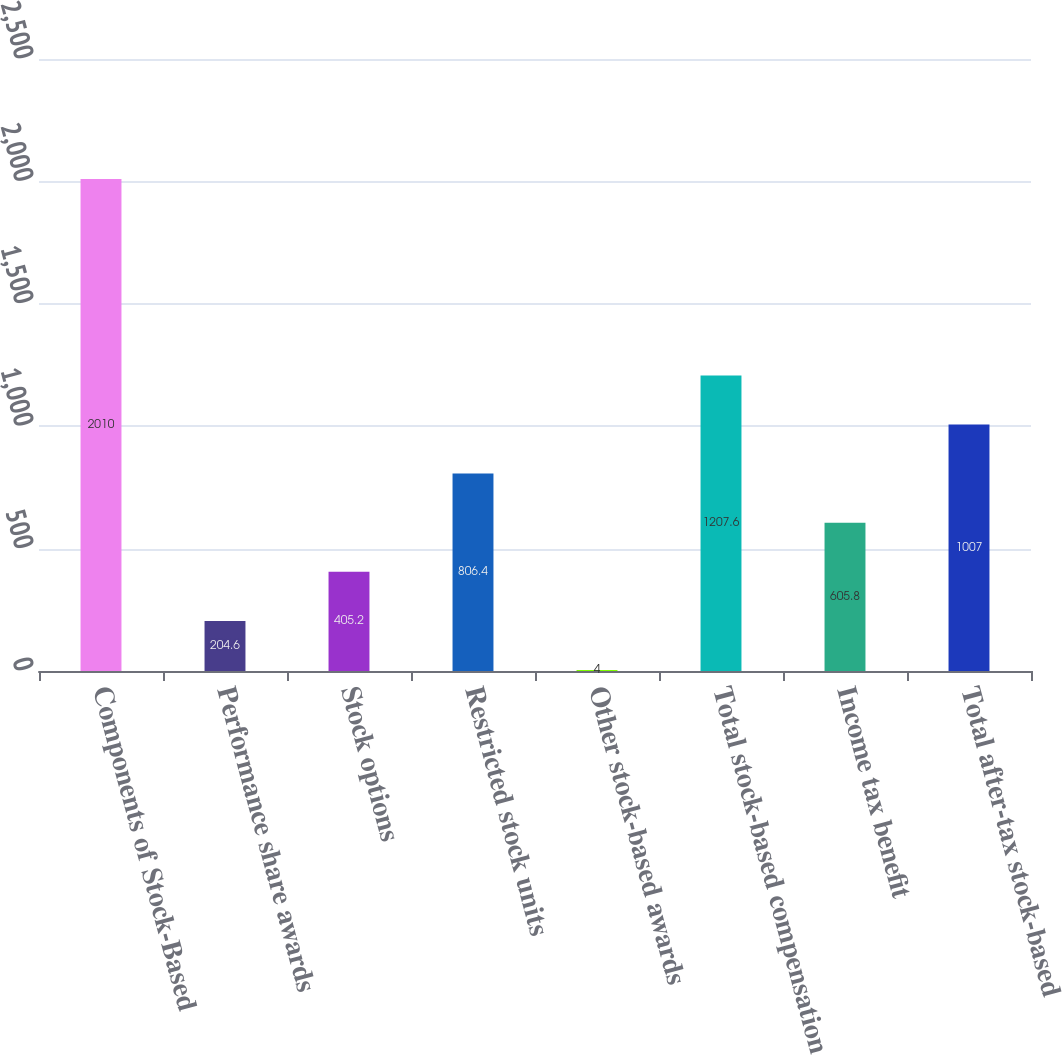<chart> <loc_0><loc_0><loc_500><loc_500><bar_chart><fcel>Components of Stock-Based<fcel>Performance share awards<fcel>Stock options<fcel>Restricted stock units<fcel>Other stock-based awards<fcel>Total stock-based compensation<fcel>Income tax benefit<fcel>Total after-tax stock-based<nl><fcel>2010<fcel>204.6<fcel>405.2<fcel>806.4<fcel>4<fcel>1207.6<fcel>605.8<fcel>1007<nl></chart> 